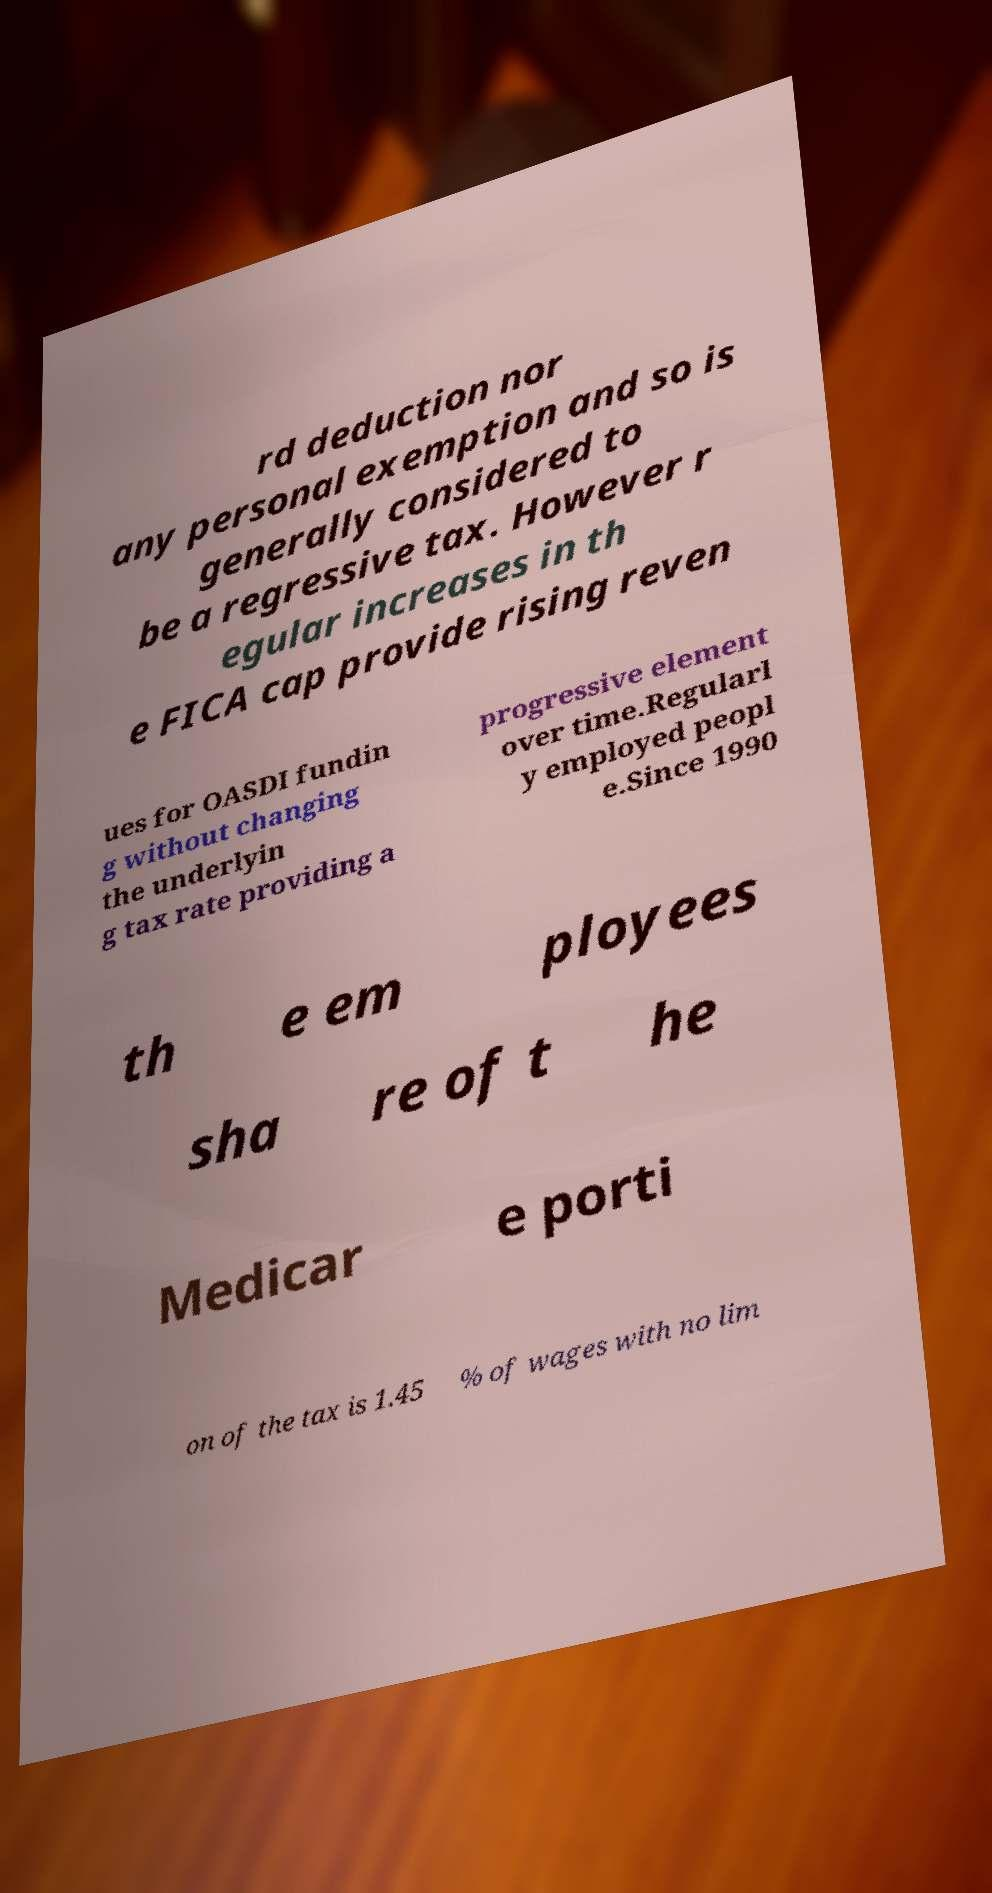What messages or text are displayed in this image? I need them in a readable, typed format. rd deduction nor any personal exemption and so is generally considered to be a regressive tax. However r egular increases in th e FICA cap provide rising reven ues for OASDI fundin g without changing the underlyin g tax rate providing a progressive element over time.Regularl y employed peopl e.Since 1990 th e em ployees sha re of t he Medicar e porti on of the tax is 1.45 % of wages with no lim 